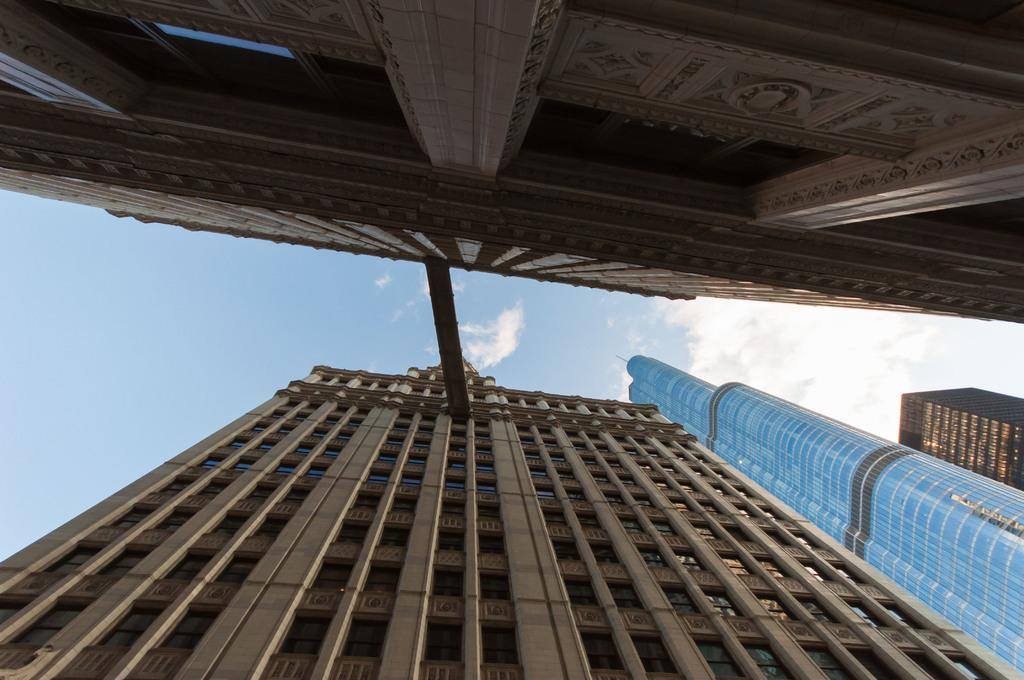What type of structures can be seen in the image? There are buildings in the image. What is visible in the background of the image? The sky is visible in the background of the image. What can be observed in the sky? There are clouds in the sky. What song is being sung by the spy in the image? There is no spy or song present in the image; it features buildings and a sky with clouds. 